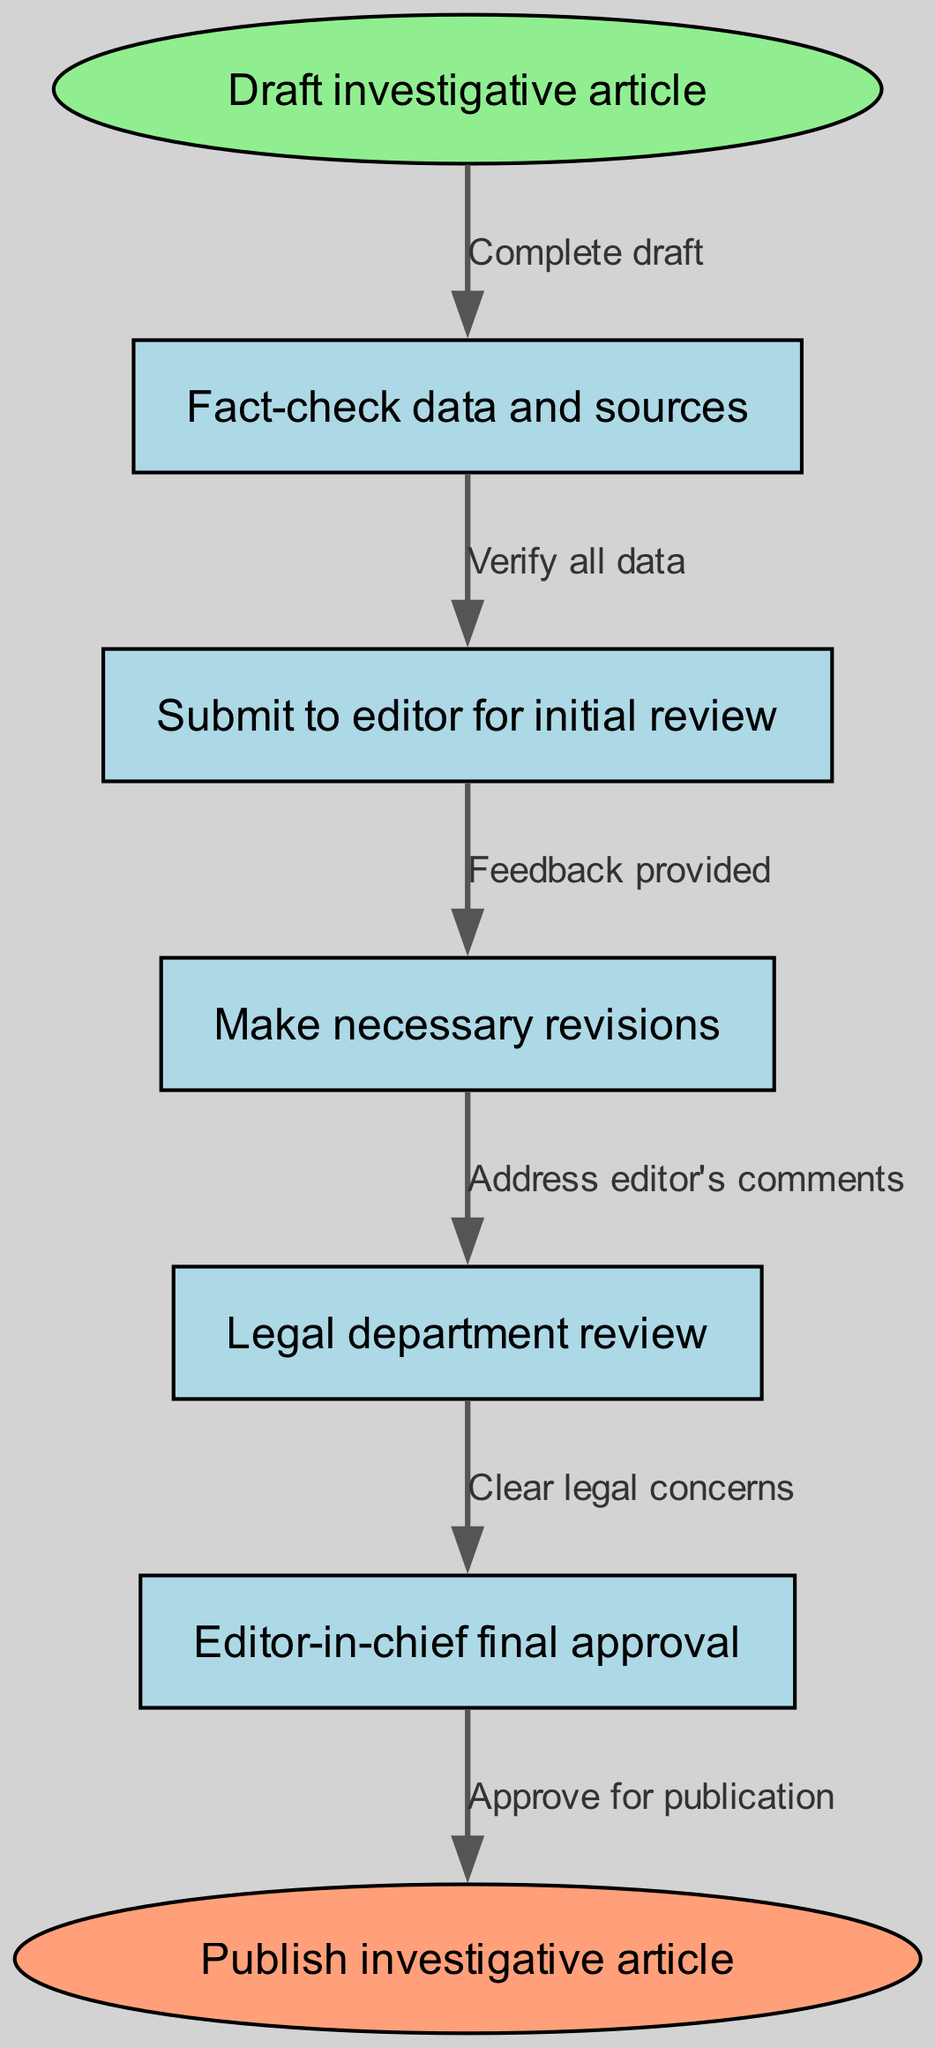What is the starting point of the workflow? The diagram indicates the starting point of the workflow with the node labeled "Draft investigative article."
Answer: Draft investigative article How many nodes are present in this workflow? By counting the distinct nodes in the diagram, I see there are five specific workflow steps besides the start and end nodes.
Answer: 5 What is the first action after completing the draft? The diagram shows that after completing the draft, the first action taken is to "Fact-check data and sources."
Answer: Fact-check data and sources What must be cleared in the legal review step? The edge leading to the final approval indicates that the legal review step focuses on "Clear legal concerns."
Answer: Clear legal concerns What must be addressed before the legal review? Looking at the flow, the revisions are to be made after obtaining feedback from the editor; therefore, "Address editor's comments" is the required action.
Answer: Address editor's comments Which step requires feedback from the editor? The diagram maps that the step where feedback is gathered is right after the initial review stage, namely the "Submit to editor for initial review" stage.
Answer: Submit to editor for initial review What is the final step in the workflow? According to the diagram, the workflow culminates with the action labeled "Approve for publication."
Answer: Approve for publication Which node follows the fact-checking step? After fact-checking data and sources, the next step shown in the diagram is "Submit to editor for initial review."
Answer: Submit to editor for initial review What role does the editor-in-chief play in the workflow? The diagram specifies that the final approval is given by the editor-in-chief, making their role crucial in the approval process for publication.
Answer: Editor-in-chief final approval 